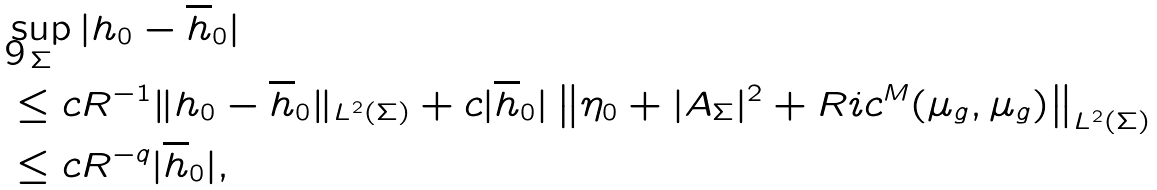Convert formula to latex. <formula><loc_0><loc_0><loc_500><loc_500>& \sup _ { \Sigma } | h _ { 0 } - \overline { h } _ { 0 } | \\ & \leq c R ^ { - 1 } \| h _ { 0 } - \overline { h } _ { 0 } \| _ { L ^ { 2 } ( \Sigma ) } + c | \overline { h } _ { 0 } | \left \| \eta _ { 0 } + | A _ { \Sigma } | ^ { 2 } + R i c ^ { M } ( \mu _ { g } , \mu _ { g } ) \right \| _ { L ^ { 2 } ( \Sigma ) } \\ & \leq c R ^ { - q } | \overline { h } _ { 0 } | ,</formula> 